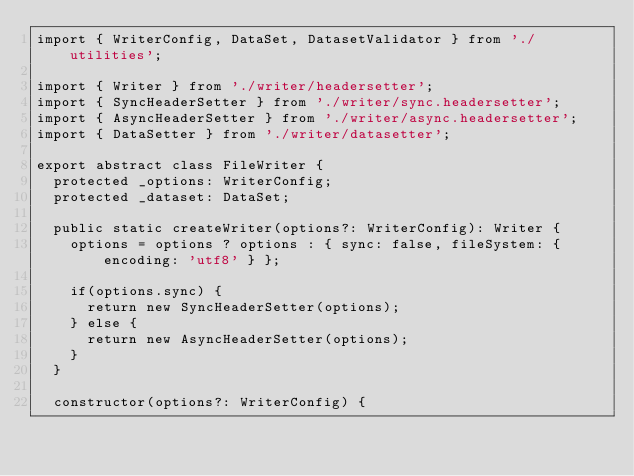Convert code to text. <code><loc_0><loc_0><loc_500><loc_500><_TypeScript_>import { WriterConfig, DataSet, DatasetValidator } from './utilities';

import { Writer } from './writer/headersetter';
import { SyncHeaderSetter } from './writer/sync.headersetter';
import { AsyncHeaderSetter } from './writer/async.headersetter';
import { DataSetter } from './writer/datasetter';

export abstract class FileWriter {
  protected _options: WriterConfig;
  protected _dataset: DataSet;

  public static createWriter(options?: WriterConfig): Writer {
    options = options ? options : { sync: false, fileSystem: { encoding: 'utf8' } };

    if(options.sync) {
      return new SyncHeaderSetter(options);
    } else {
      return new AsyncHeaderSetter(options);
    }
  }

  constructor(options?: WriterConfig) {</code> 